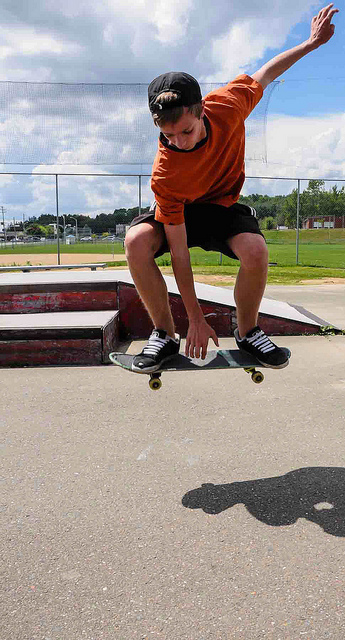What trick might the skateboarder be performing? The skateboarder appears to be performing an 'ollie', a basic trick where both the rider and the board leap into the air without the use of the rider's hands. Is it a difficult trick to learn? For beginners, an ollie can be challenging to master. It requires proper timing, balance, and coordination, but it serves as a foundational move for many more complex tricks. 